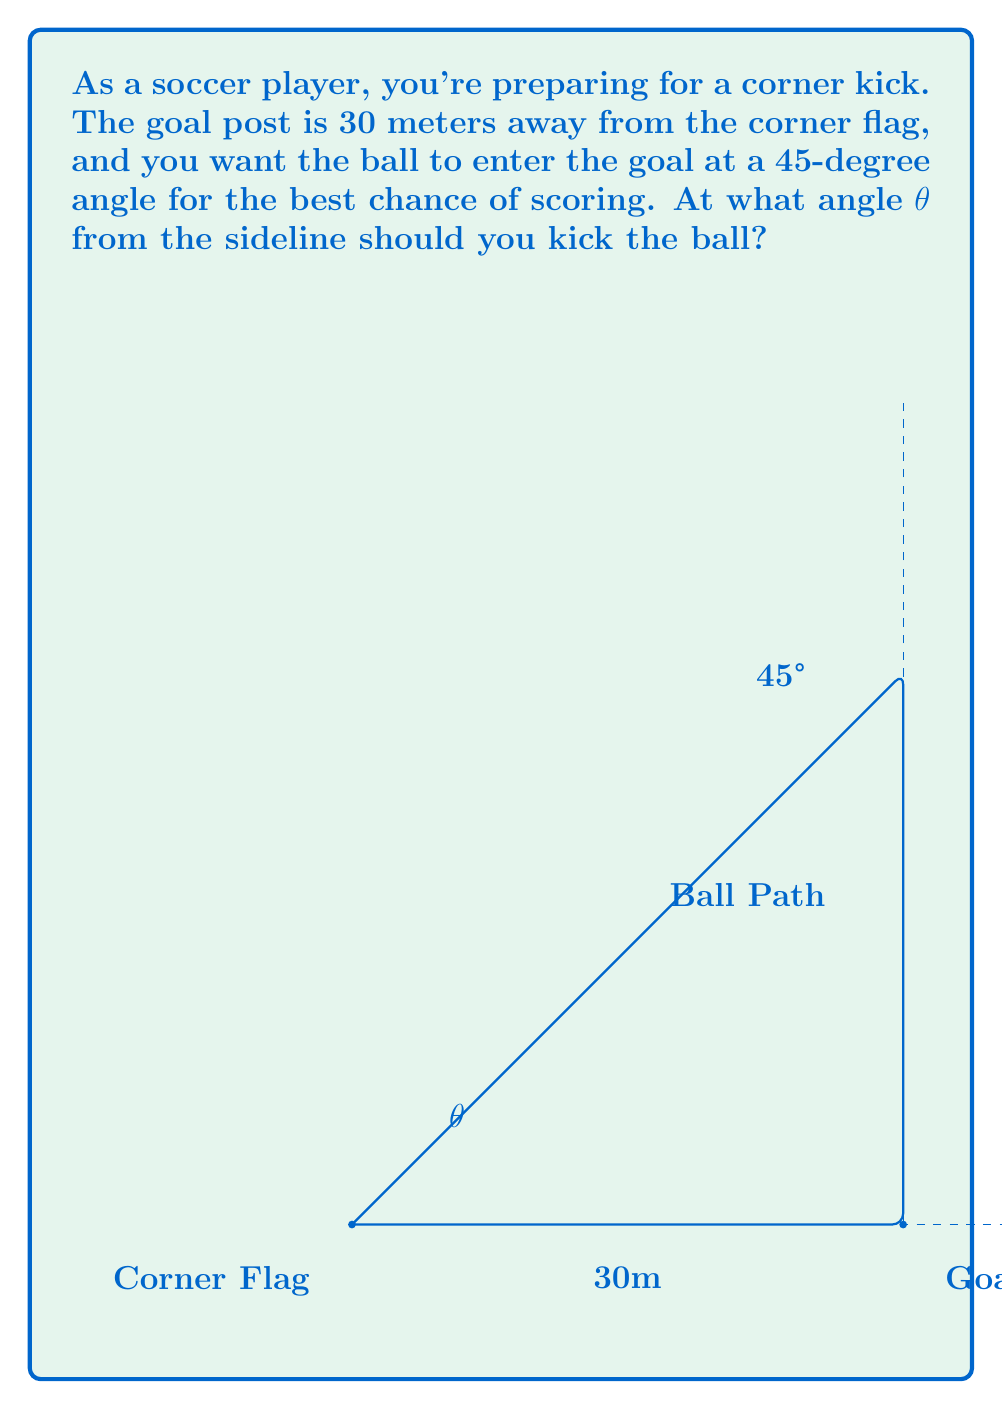Help me with this question. Let's approach this step-by-step using trigonometry:

1) We can treat this as a right triangle problem. The corner flag is at one vertex, the goal post at another, and the point where the ball enters the goal at the third vertex.

2) We know two things about this triangle:
   - The distance from the corner flag to the goal post is 30 meters
   - The angle at which the ball enters the goal is 45°

3) Let's call the angle we're looking for θ. This is the angle between the sideline and the path of the ball.

4) In this right triangle:
   - The hypotenuse is the path of the ball
   - The adjacent side to θ is 30 meters (distance to goal post)
   - The opposite side to θ is equal to the adjacent side (because the angle at the goal is 45°)

5) We can use the tangent function to find θ:

   $$\tan(\theta) = \frac{\text{opposite}}{\text{adjacent}} = \frac{30}{30} = 1$$

6) To find θ, we need to take the inverse tangent (arctangent):

   $$\theta = \arctan(1)$$

7) We know that $\arctan(1) = 45°$

Therefore, the angle θ at which you should kick the ball is 45° from the sideline.
Answer: 45° 